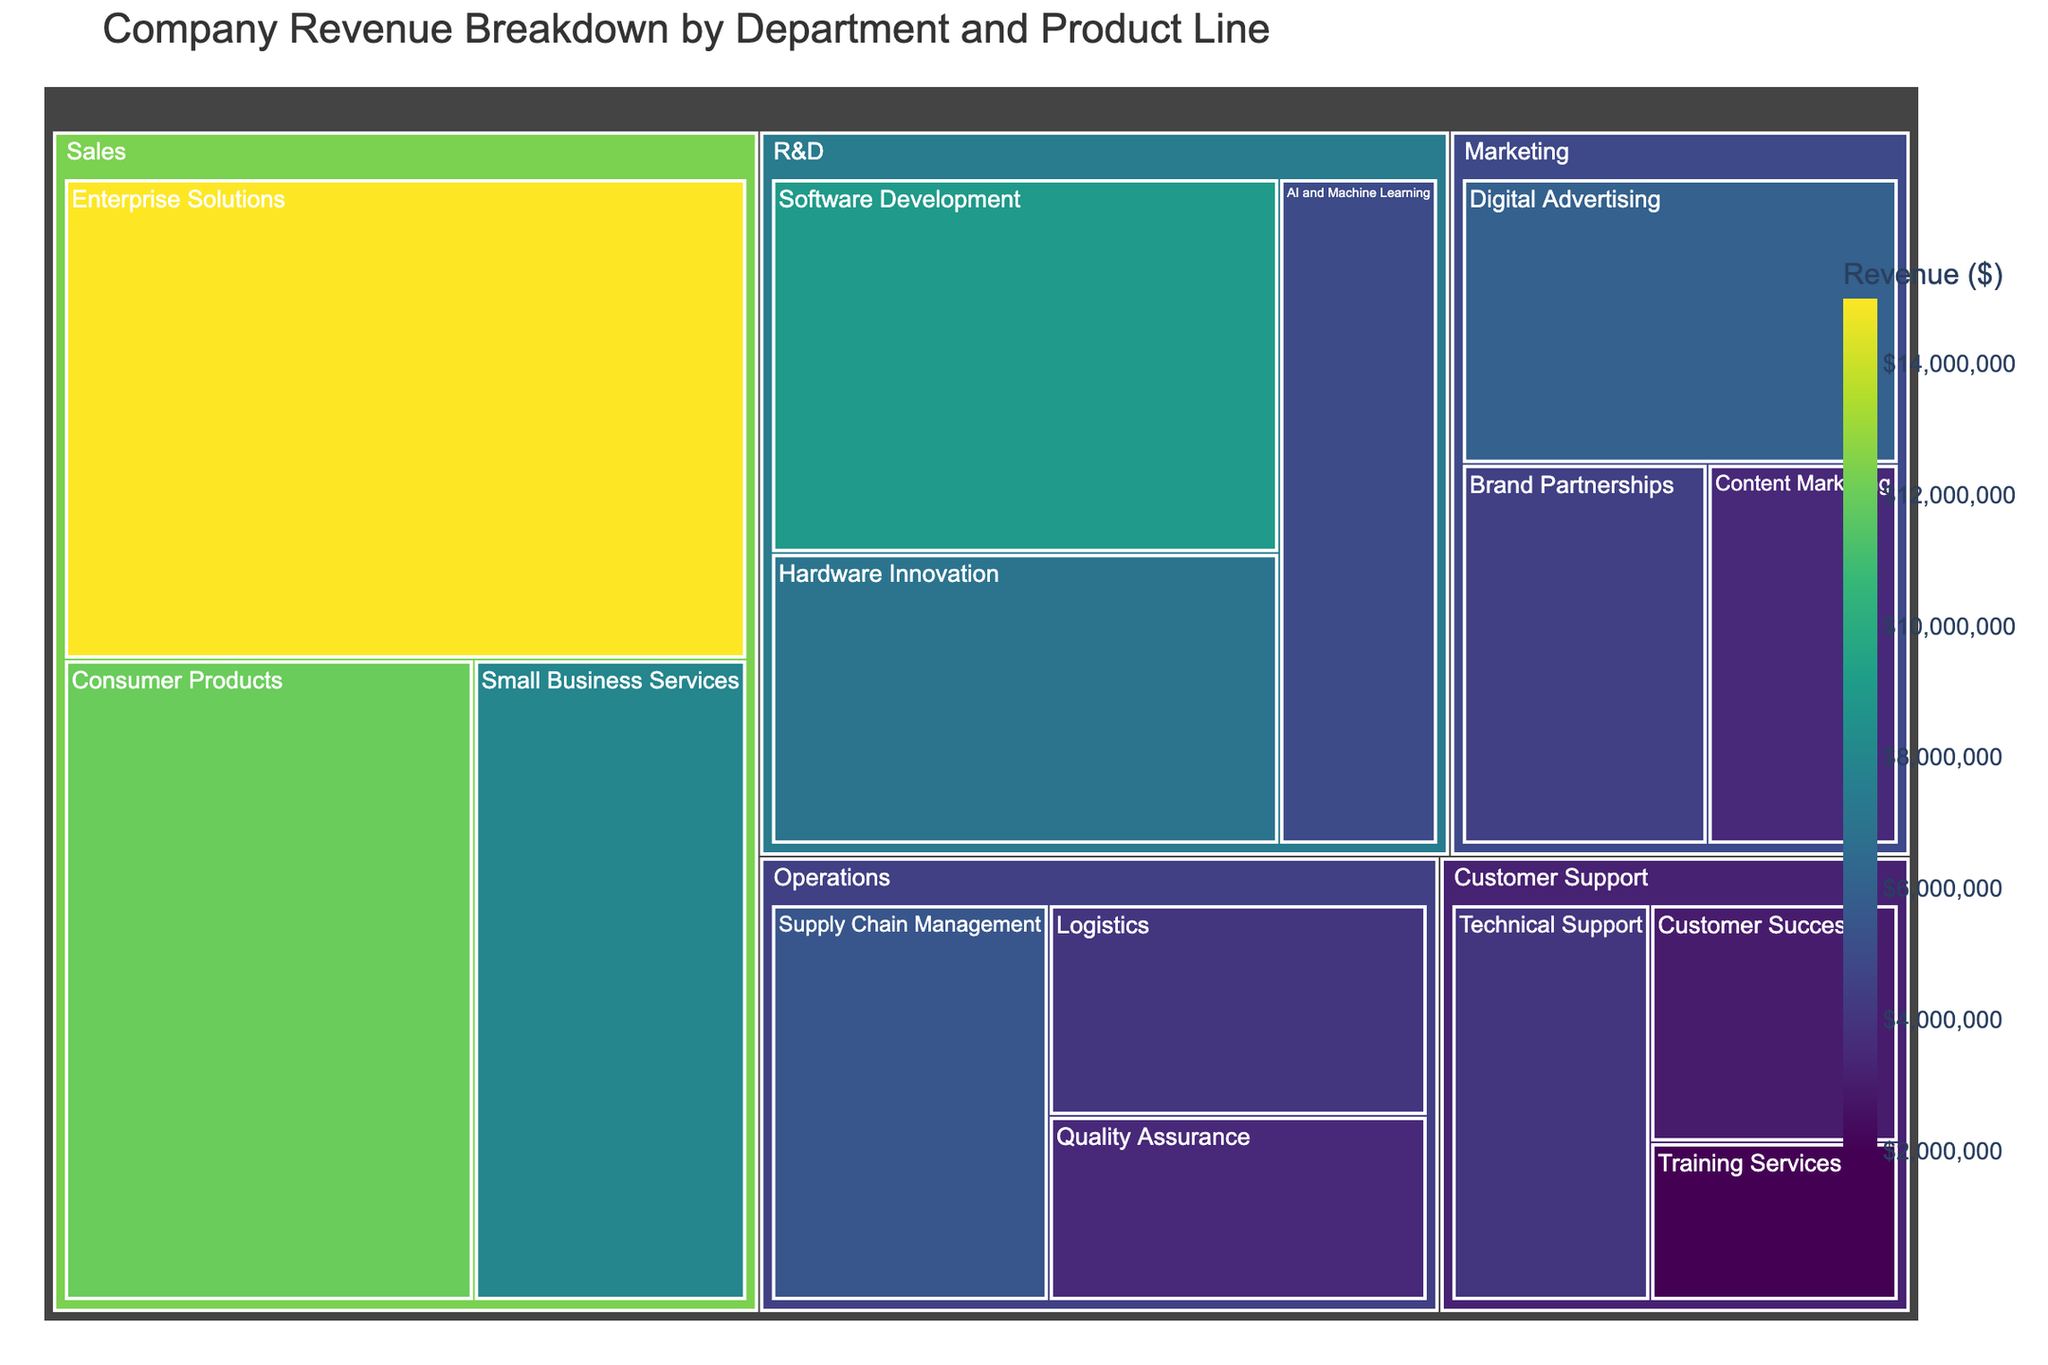What's the title of the figure? The title is prominently displayed at the top of the figure on a treemap. You can identify it quickly by looking for the largest and typically bolded text.
Answer: Company Revenue Breakdown by Department and Product Line Which department has the highest total revenue? Look for the department with the largest area in the treemap. The size of each area represents the revenue, so the largest area corresponds to the highest total revenue.
Answer: Sales What is the revenue of the 'Digital Advertising' product line? The treemap shows individual product lines, and hovering over or checking the label for ‘Digital Advertising’ will reveal its revenue.
Answer: $6,000,000 Which product line within the Sales department generates the least revenue? Within the Sales department, compare the areas of each product line tile. The smallest area will correspond to the product line with the least revenue.
Answer: Small Business Services What's the combined revenue of the 'Training Services' and 'Quality Assurance' product lines? Identify the revenue amounts for 'Training Services' and 'Quality Assurance' from the treemap, then sum these values: 2,000,000 + 3,500,000.
Answer: $5,500,000 Which department has the lowest total revenue? Compare the areas of all department tiles in the treemap. The department with the smallest total area will have the lowest revenue.
Answer: Customer Support How much more revenue does 'Enterprise Solutions' generate compared to 'Supply Chain Management'? Find the revenue for both product lines and then calculate the difference: 15,000,000 - 5,500,000.
Answer: $9,500,000 What is the average revenue of the product lines within the Marketing department? Identify the revenue of all product lines within Marketing (6,000,000 + 4,500,000 + 3,500,000), then divide by the number of product lines (3).
Answer: $4,666,667 Which product line within R&D has the highest revenue? Within the R&D department, compare the areas of product line tiles. The largest area corresponds to the product line with the highest revenue.
Answer: Software Development In the Operations department, which product line has less revenue than 'Logistics' but more than 'Quality Assurance'? First, note the revenue for 'Logistics' and 'Quality Assurance'. Check for the third product line in Operations whose revenue lies between these two values.
Answer: Supply Chain Management 